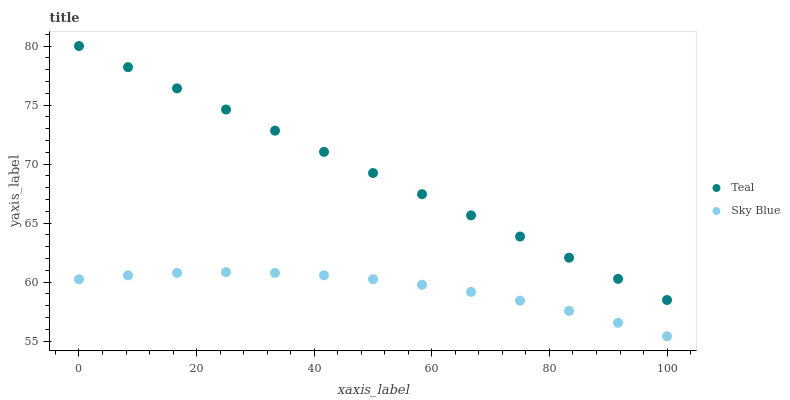Does Sky Blue have the minimum area under the curve?
Answer yes or no. Yes. Does Teal have the maximum area under the curve?
Answer yes or no. Yes. Does Teal have the minimum area under the curve?
Answer yes or no. No. Is Teal the smoothest?
Answer yes or no. Yes. Is Sky Blue the roughest?
Answer yes or no. Yes. Is Teal the roughest?
Answer yes or no. No. Does Sky Blue have the lowest value?
Answer yes or no. Yes. Does Teal have the lowest value?
Answer yes or no. No. Does Teal have the highest value?
Answer yes or no. Yes. Is Sky Blue less than Teal?
Answer yes or no. Yes. Is Teal greater than Sky Blue?
Answer yes or no. Yes. Does Sky Blue intersect Teal?
Answer yes or no. No. 